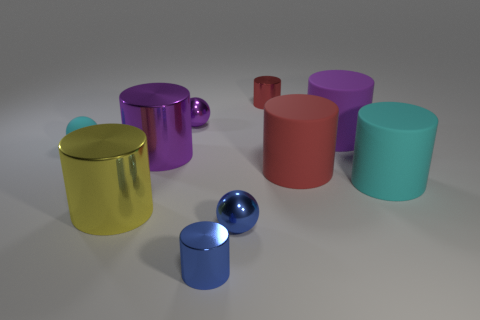How is the lighting in the scene affecting the appearance of the objects? The lighting appears to be soft and diffused, casting gentle shadows and subtle highlights on the objects, which give them a three-dimensional look and enhance the perception of their shapes. 